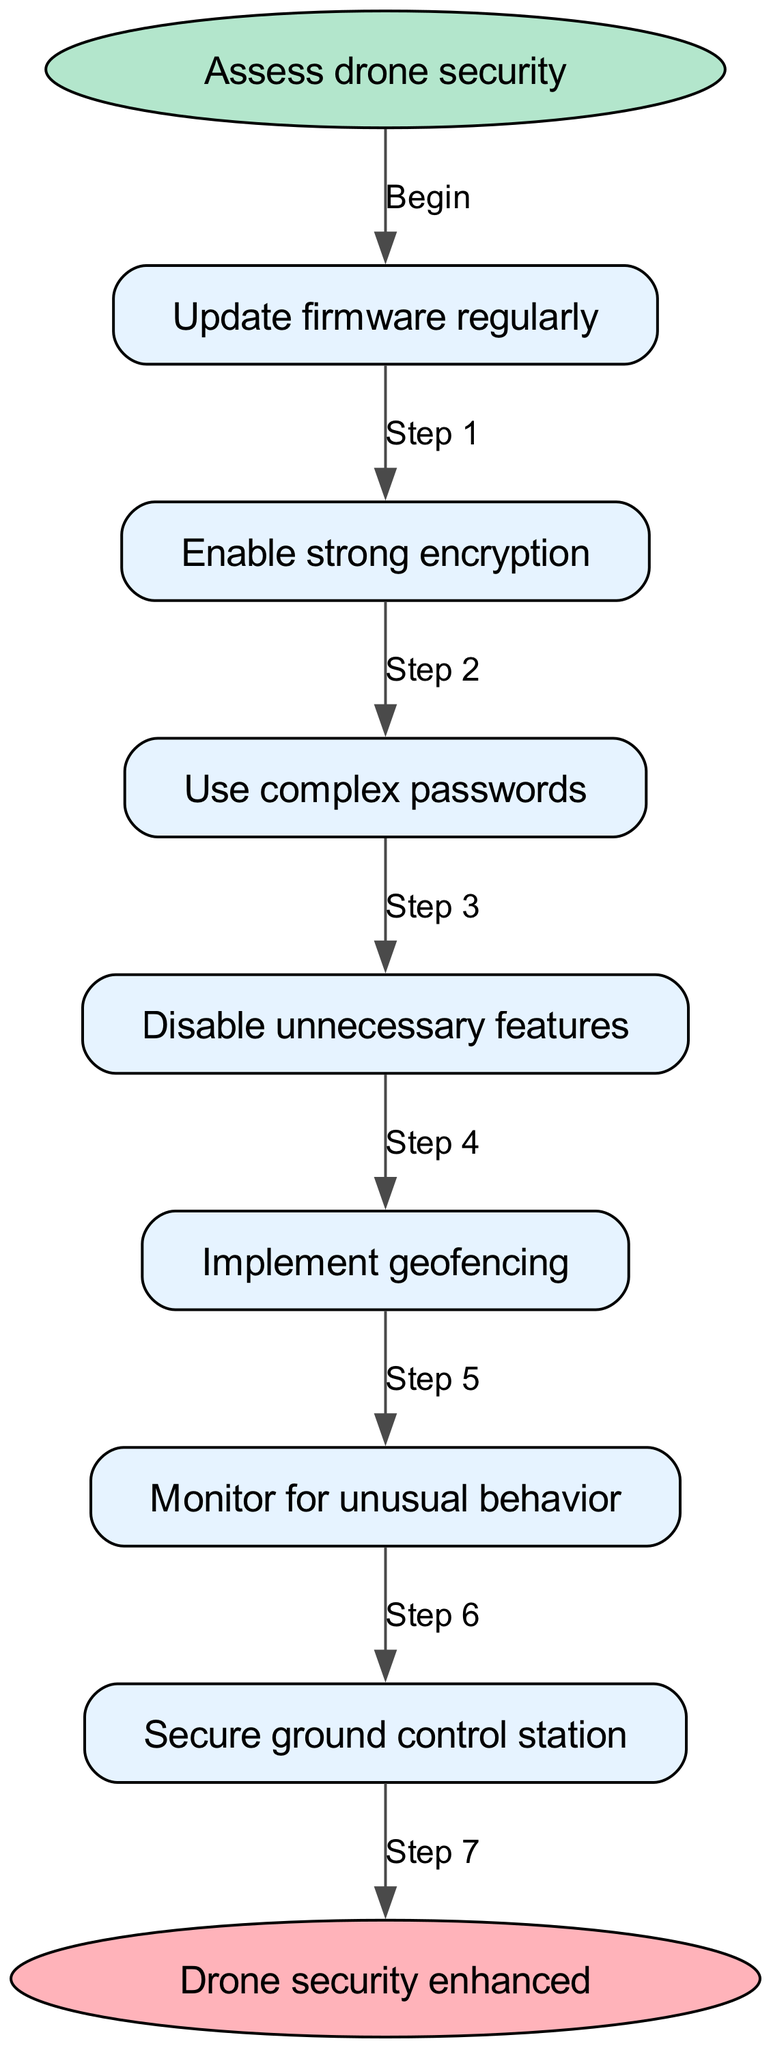What is the first step in securing a drone? The first step in the diagram is labeled "Update firmware regularly," which follows directly after the "Assess drone security" node. This indicates that the action to be taken right after the initial assessment is to update the firmware.
Answer: Update firmware regularly How many steps are there in total? Counting the steps listed in the diagram, there are seven individual steps from "Update firmware regularly" to "Secure ground control station." Therefore, the total number of steps is 7.
Answer: 7 What step comes after "Disable unnecessary features"? In the flow chart, "Disable unnecessary features" is followed by the step labeled "Implement geofencing." This connection shows the sequence from disabling features to implementing geofencing as part of the security measures.
Answer: Implement geofencing What does the last step in the process indicate? The last step is labeled "Drone security enhanced," which signifies the conclusion of the steps taken to secure the drone. This implies that all preceding steps contribute towards enhancing the overall security of the drone.
Answer: Drone security enhanced Which step involves monitoring? The step labeled "Monitor for unusual behavior" directly addresses the need for vigilance after implementing security measures. This suggests that ongoing monitoring is crucial to identify any potential threats following the previous steps.
Answer: Monitor for unusual behavior Is "Use complex passwords" the third step? Yes, the diagram specifies that "Use complex passwords" is exactly the third step in the sequence of actions outlined for securing the drone, following the steps of updating firmware and enabling encryption.
Answer: Yes What is the relationship between "Enable strong encryption" and "Update firmware regularly"? The diagram shows a direct progression from "Update firmware regularly" to "Enable strong encryption," signifying that after updating the firmware, the next security measure to implement is enabling strong encryption.
Answer: Direct progression 